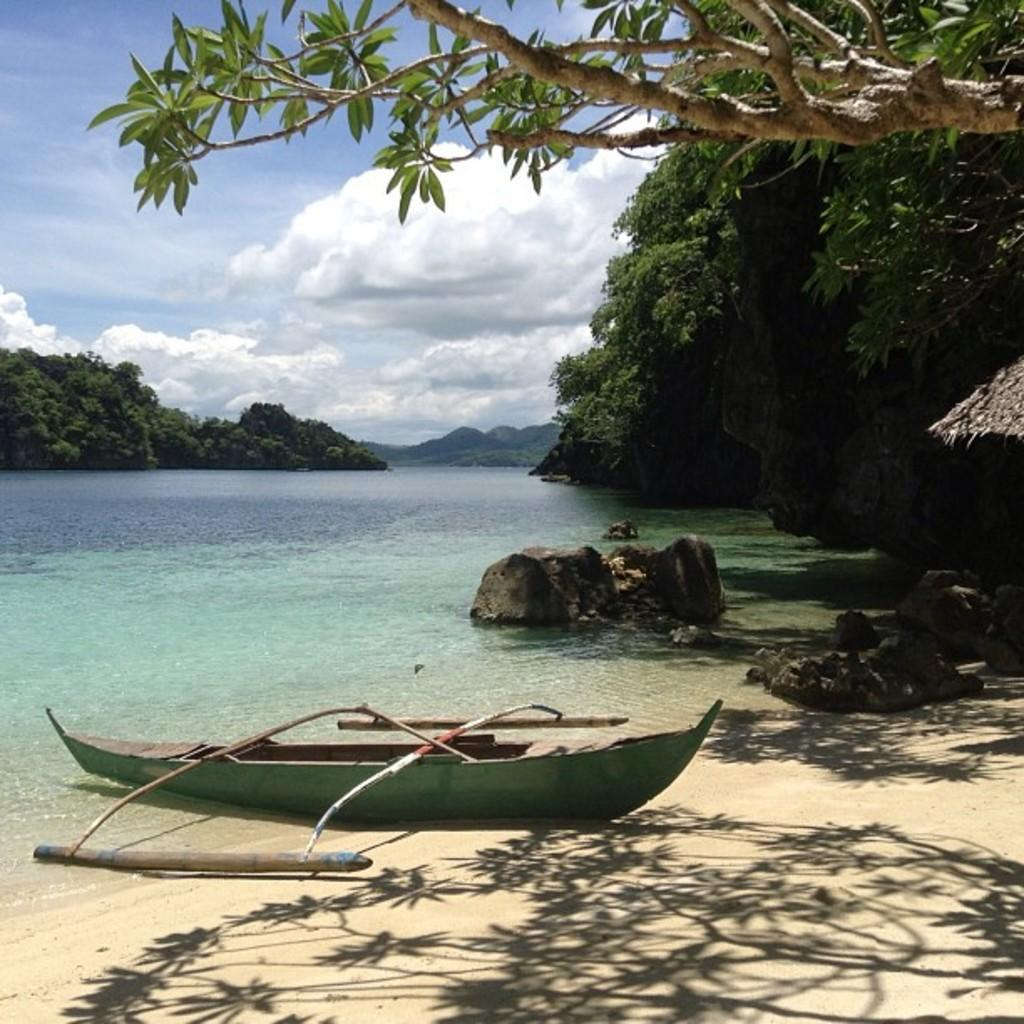What is the condition of the sky in the image? The sky is cloudy in the image. What type of vegetation is near the water? There are trees near the water in the image. What can be seen floating on the water? Boats are visible in the image. What type of cream is being used to paint the end of the bucket in the image? There is no bucket or painting activity present in the image. How many buckets can be seen in the image? There are no buckets present in the image. 